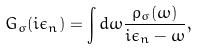Convert formula to latex. <formula><loc_0><loc_0><loc_500><loc_500>G _ { \sigma } ( i \epsilon _ { n } ) = \int d \omega \frac { \rho _ { \sigma } ( \omega ) } { i \epsilon _ { n } - \omega } ,</formula> 